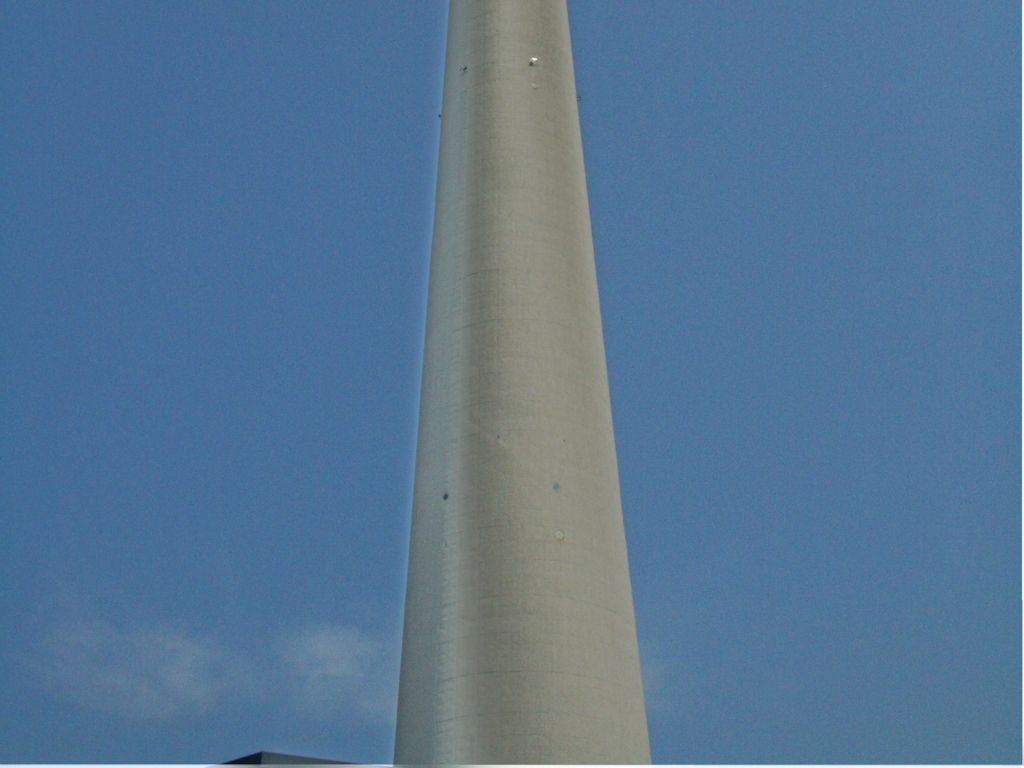Are there any quality issues with this image? The image is clear and in focus, capturing a large concrete structure against the sky. However, there is a noticeable lack of context, which makes it challenging to discern the exact nature or purpose of the structure. A potential quality issue is the composition; the image is framed in such a manner that most of the structure is cut off, providing only a partial view that limits the understanding of its scale and design. 